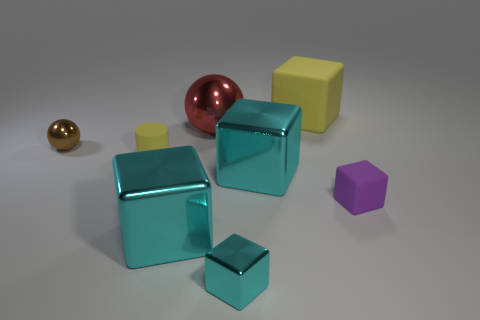Do the brown shiny object and the yellow thing behind the rubber cylinder have the same size?
Provide a short and direct response. No. There is a tiny block that is on the left side of the yellow rubber block; what material is it?
Provide a short and direct response. Metal. How many things are both on the right side of the tiny brown sphere and to the left of the yellow cube?
Provide a short and direct response. 5. There is a yellow object that is the same size as the red shiny ball; what is its material?
Offer a very short reply. Rubber. Does the cyan block behind the small purple matte object have the same size as the cyan shiny cube that is on the left side of the large red shiny thing?
Offer a very short reply. Yes. Are there any large cyan shiny cubes left of the small yellow matte cylinder?
Give a very brief answer. No. There is a tiny cube that is behind the cyan block left of the tiny cyan object; what color is it?
Make the answer very short. Purple. Are there fewer small matte cylinders than big red metallic cubes?
Give a very brief answer. No. What number of small yellow matte objects are the same shape as the large red metallic object?
Provide a short and direct response. 0. What is the color of the other block that is the same size as the purple matte block?
Ensure brevity in your answer.  Cyan. 